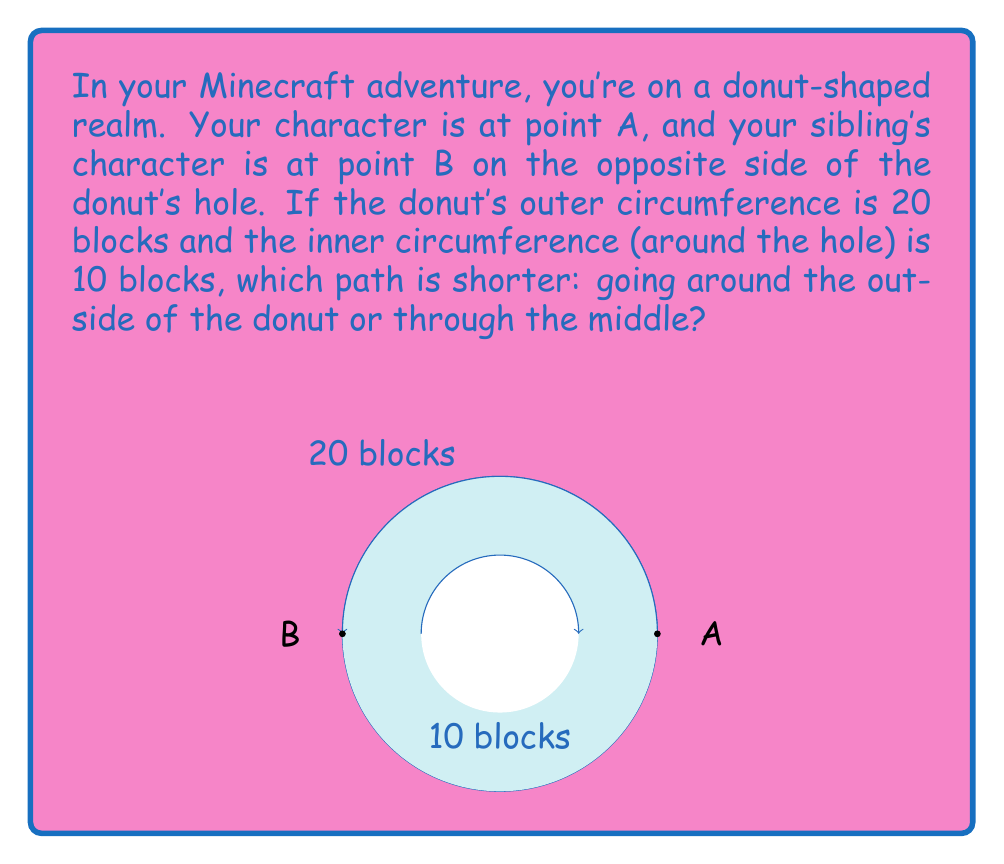Give your solution to this math problem. Let's think about this step-by-step:

1. The donut shape is called a torus in geometry. On a torus, we have two main paths between points on opposite sides:
   - Around the outside (the longer way)
   - Through the middle (the shorter way)

2. The outer path:
   - The outer circumference is 20 blocks
   - Half of this circumference is the distance between A and B going the long way
   - So, the outer path length is: $20 \div 2 = 10$ blocks

3. The inner path:
   - The inner circumference (around the hole) is 10 blocks
   - Half of this circumference is the distance between A and B going through the middle
   - So, the inner path length is: $10 \div 2 = 5$ blocks

4. Comparing the two paths:
   - Outer path: 10 blocks
   - Inner path: 5 blocks

5. The inner path through the middle is shorter!

This shows that on a donut shape (torus), the shortest path between two points isn't always a straight line like in flat Minecraft worlds. Sometimes, it's better to go through the hole!
Answer: The path through the middle (5 blocks) is shorter. 